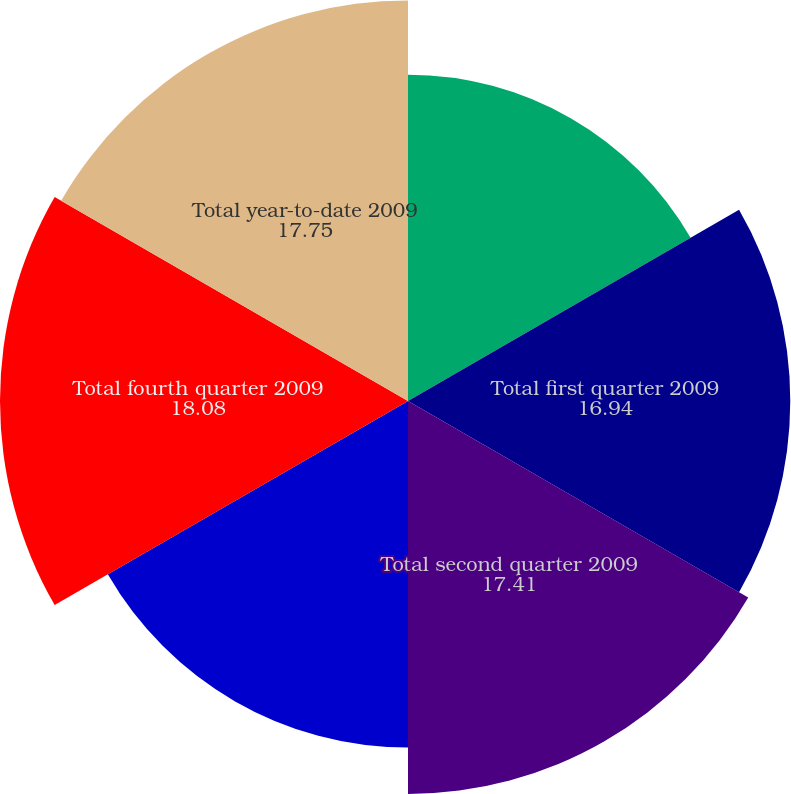Convert chart. <chart><loc_0><loc_0><loc_500><loc_500><pie_chart><fcel>Open market repurchases (1)<fcel>Total first quarter 2009<fcel>Total second quarter 2009<fcel>Total third quarter 2009<fcel>Total fourth quarter 2009<fcel>Total year-to-date 2009<nl><fcel>14.46%<fcel>16.94%<fcel>17.41%<fcel>15.36%<fcel>18.08%<fcel>17.75%<nl></chart> 